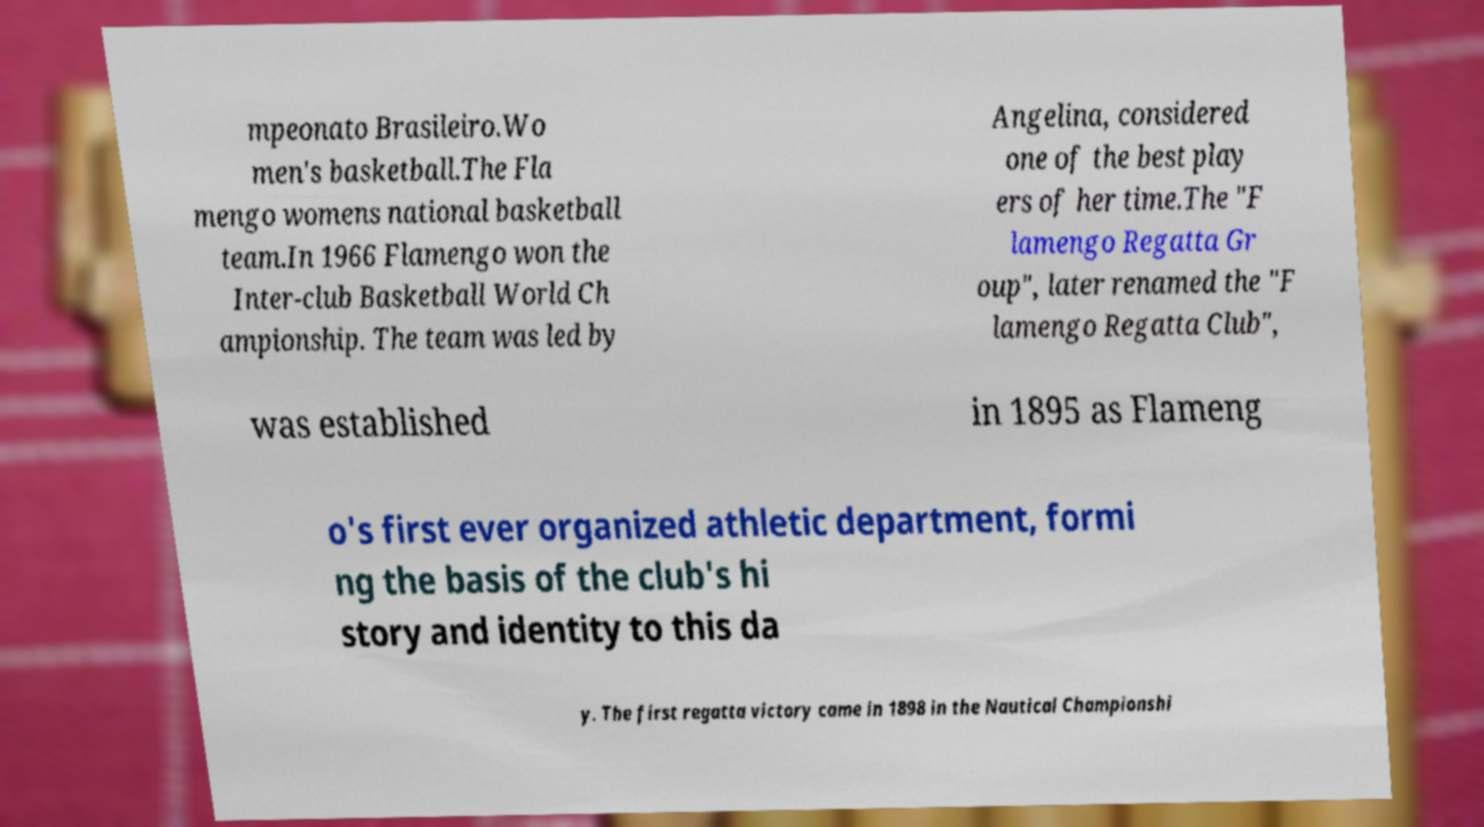There's text embedded in this image that I need extracted. Can you transcribe it verbatim? mpeonato Brasileiro.Wo men's basketball.The Fla mengo womens national basketball team.In 1966 Flamengo won the Inter-club Basketball World Ch ampionship. The team was led by Angelina, considered one of the best play ers of her time.The "F lamengo Regatta Gr oup", later renamed the "F lamengo Regatta Club", was established in 1895 as Flameng o's first ever organized athletic department, formi ng the basis of the club's hi story and identity to this da y. The first regatta victory came in 1898 in the Nautical Championshi 